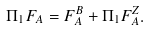<formula> <loc_0><loc_0><loc_500><loc_500>\Pi _ { 1 } F _ { A } = F _ { A } ^ { B } + \Pi _ { 1 } F _ { A } ^ { Z } .</formula> 